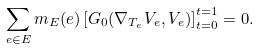Convert formula to latex. <formula><loc_0><loc_0><loc_500><loc_500>\sum _ { e \in E } m _ { E } ( e ) \left [ G _ { 0 } ( \nabla _ { T _ { e } } V _ { e } , V _ { e } ) \right ] _ { t = 0 } ^ { t = 1 } = 0 .</formula> 